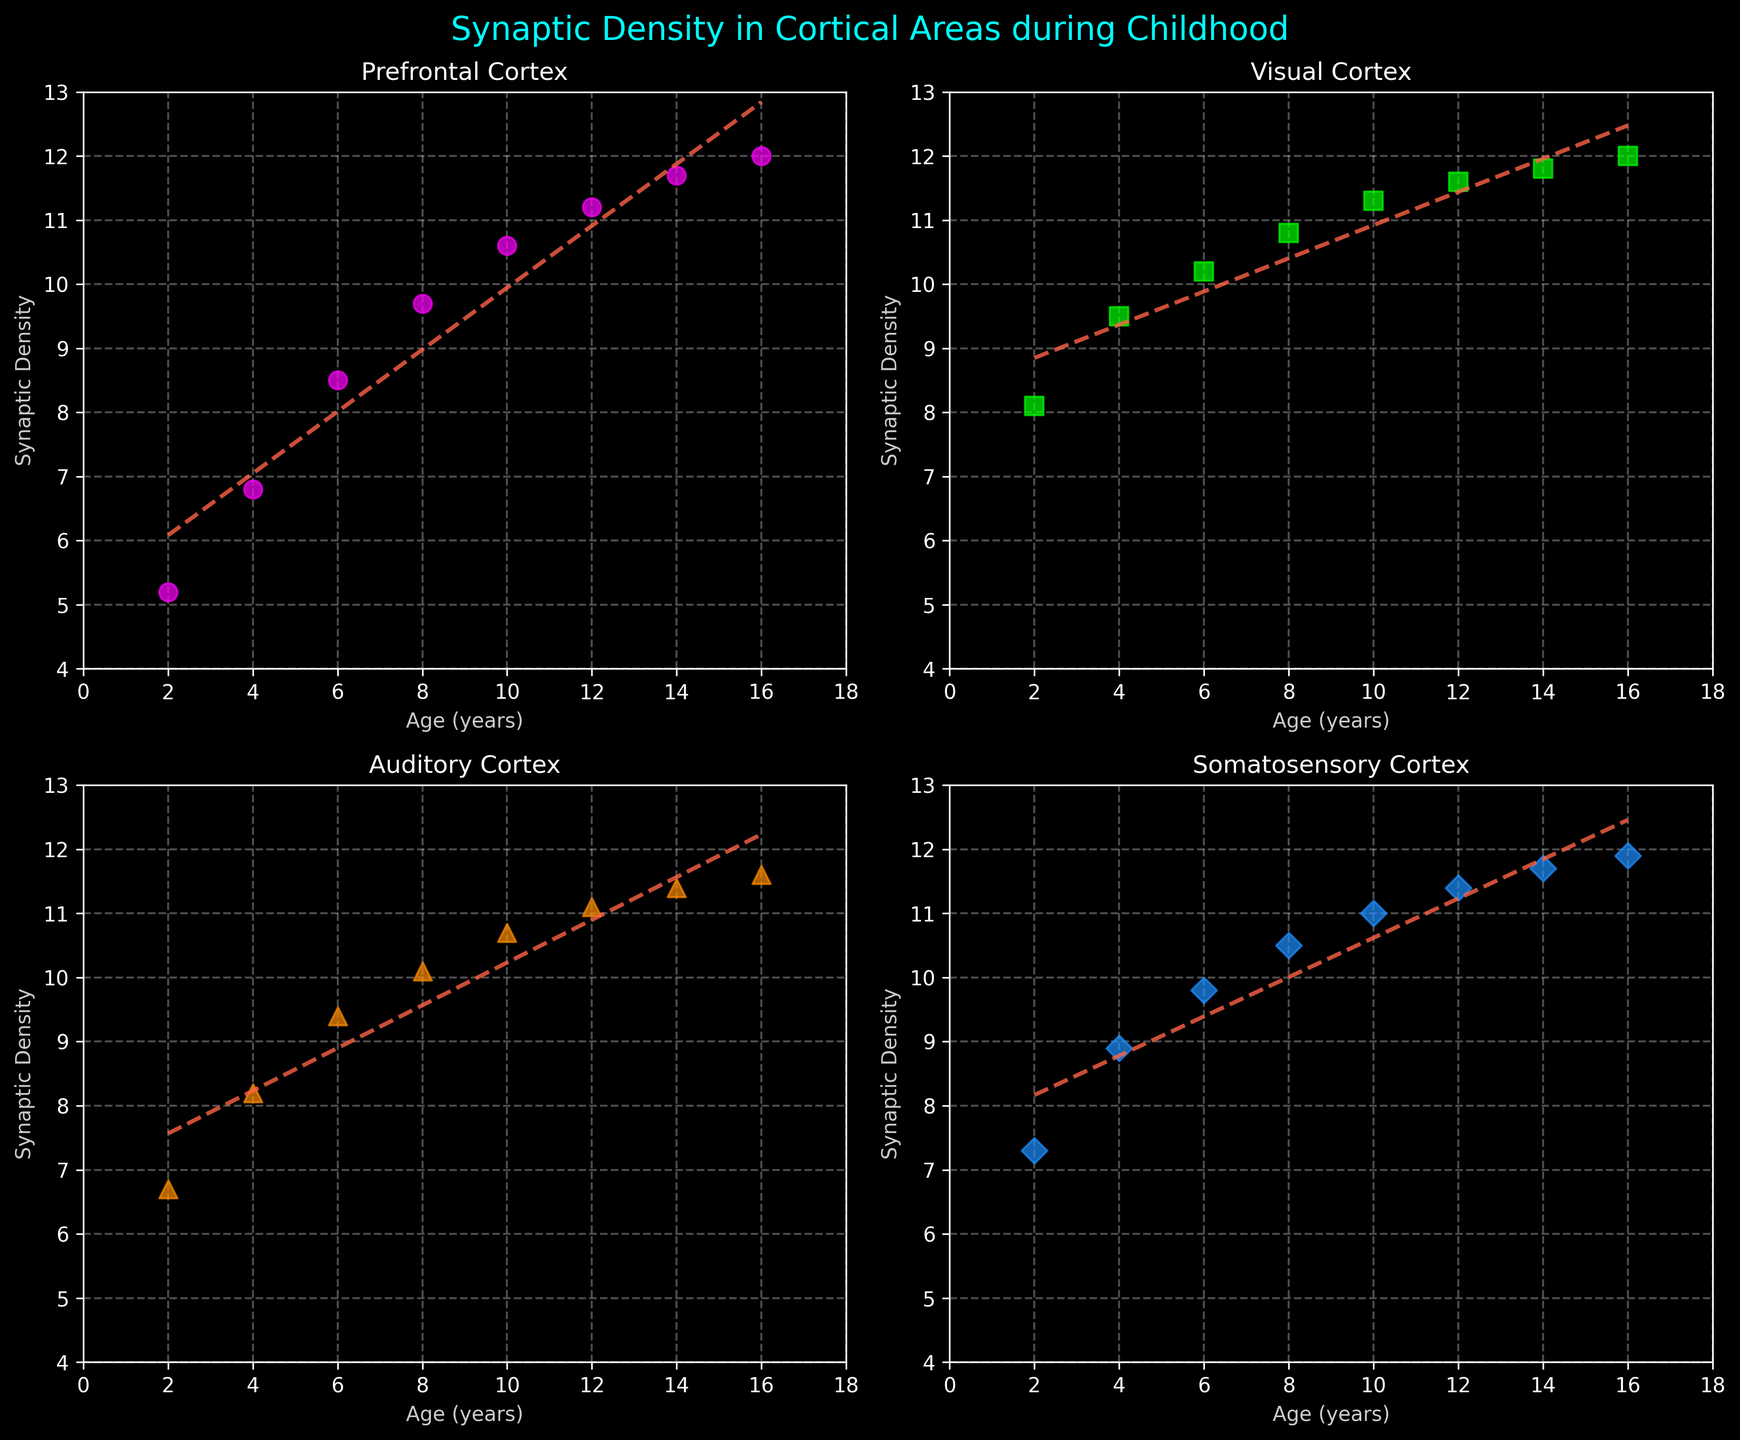What is the title of the figure? The title is usually found at the top of the figure and summarizes the main topic or content of the plot. In this case, it reads "Synaptic Density in Cortical Areas during Childhood"
Answer: Synaptic Density in Cortical Areas during Childhood What cortical area has the highest synaptic density at age 10? To determine this, look at the scatter plots for age 10 across all subplots and compare the values. The highest value at age 10 is in the Visual Cortex.
Answer: Visual Cortex How does the synaptic density in the Prefrontal Cortex change from age 2 to age 16? Examine the trend line in the Prefrontal Cortex subplot. The synaptic density increases from 5.2 at age 2 to 12.0 at age 16.
Answer: It increases What is the difference in synaptic density between the Auditory Cortex and Somatosensory Cortex at age 6? Identify the synaptic density in the Auditory Cortex and Somatosensory Cortex for age 6. The densities are 9.4 and 9.8, respectively. Subtract the Auditory Cortex value from the Somatosensory Cortex value (9.8 - 9.4).
Answer: 0.4 Which cortical area has the least increase in synaptic density from age 2 to age 16? Calculate the increase for each area by subtracting the density at age 2 from the density at age 16. The least increase corresponds to the smallest difference, which in this case is for the Visual Cortex (12.0-8.1 = 3.9).
Answer: Visual Cortex Compare the trend lines in each subplot. Which cortical area shows the steepest increase in synaptic density? Compare the slopes of the trend lines, which represent the rate of increase. The trend line with the largest positive slope (steepest) indicates the steepest increase, which is in the Prefrontal Cortex.
Answer: Prefrontal Cortex What is the average synaptic density in the Visual Cortex over the given ages? Sum the synaptic densities in the Visual Cortex at all ages and divide by the number of age points (8). (8.1 + 9.5 + 10.2 + 10.8 + 11.3 + 11.6 + 11.8 + 12.0)/8 = 10.66 (average).
Answer: 10.66 Identify the overall pattern of synaptic density in the Prefrontal Cortex from childhood to adolescence. Observe the scatter points and trend line in the Prefrontal Cortex subplot. The synaptic density consistently increases from childhood to adolescence, indicating continuous neural development in this region.
Answer: Consistent increase At age 8, rank the cortical areas from highest to lowest in synaptic density. Look at the synaptic density values at age 8 for each cortical area: Prefrontal Cortex (9.7), Visual Cortex (10.8), Auditory Cortex (10.1), Somatosensory Cortex (10.5). Rank them in descending order: Visual Cortex > Somatosensory Cortex > Auditory Cortex > Prefrontal Cortex.
Answer: Visual Cortex > Somatosensory Cortex > Auditory Cortex > Prefrontal Cortex 